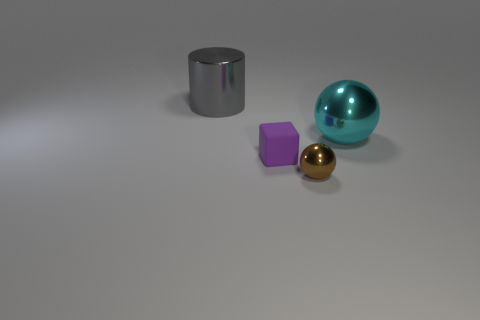Add 4 large shiny spheres. How many objects exist? 8 Subtract all blocks. How many objects are left? 3 Add 3 gray cylinders. How many gray cylinders are left? 4 Add 4 green things. How many green things exist? 4 Subtract 0 yellow balls. How many objects are left? 4 Subtract all large blue rubber cylinders. Subtract all rubber things. How many objects are left? 3 